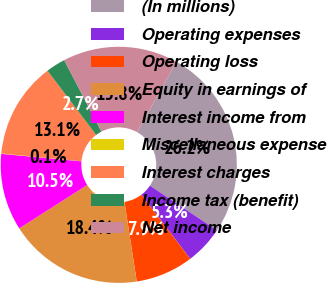<chart> <loc_0><loc_0><loc_500><loc_500><pie_chart><fcel>(In millions)<fcel>Operating expenses<fcel>Operating loss<fcel>Equity in earnings of<fcel>Interest income from<fcel>Miscellaneous expense<fcel>Interest charges<fcel>Income tax (benefit)<fcel>Net income<nl><fcel>26.24%<fcel>5.29%<fcel>7.91%<fcel>18.39%<fcel>10.53%<fcel>0.05%<fcel>13.15%<fcel>2.67%<fcel>15.77%<nl></chart> 